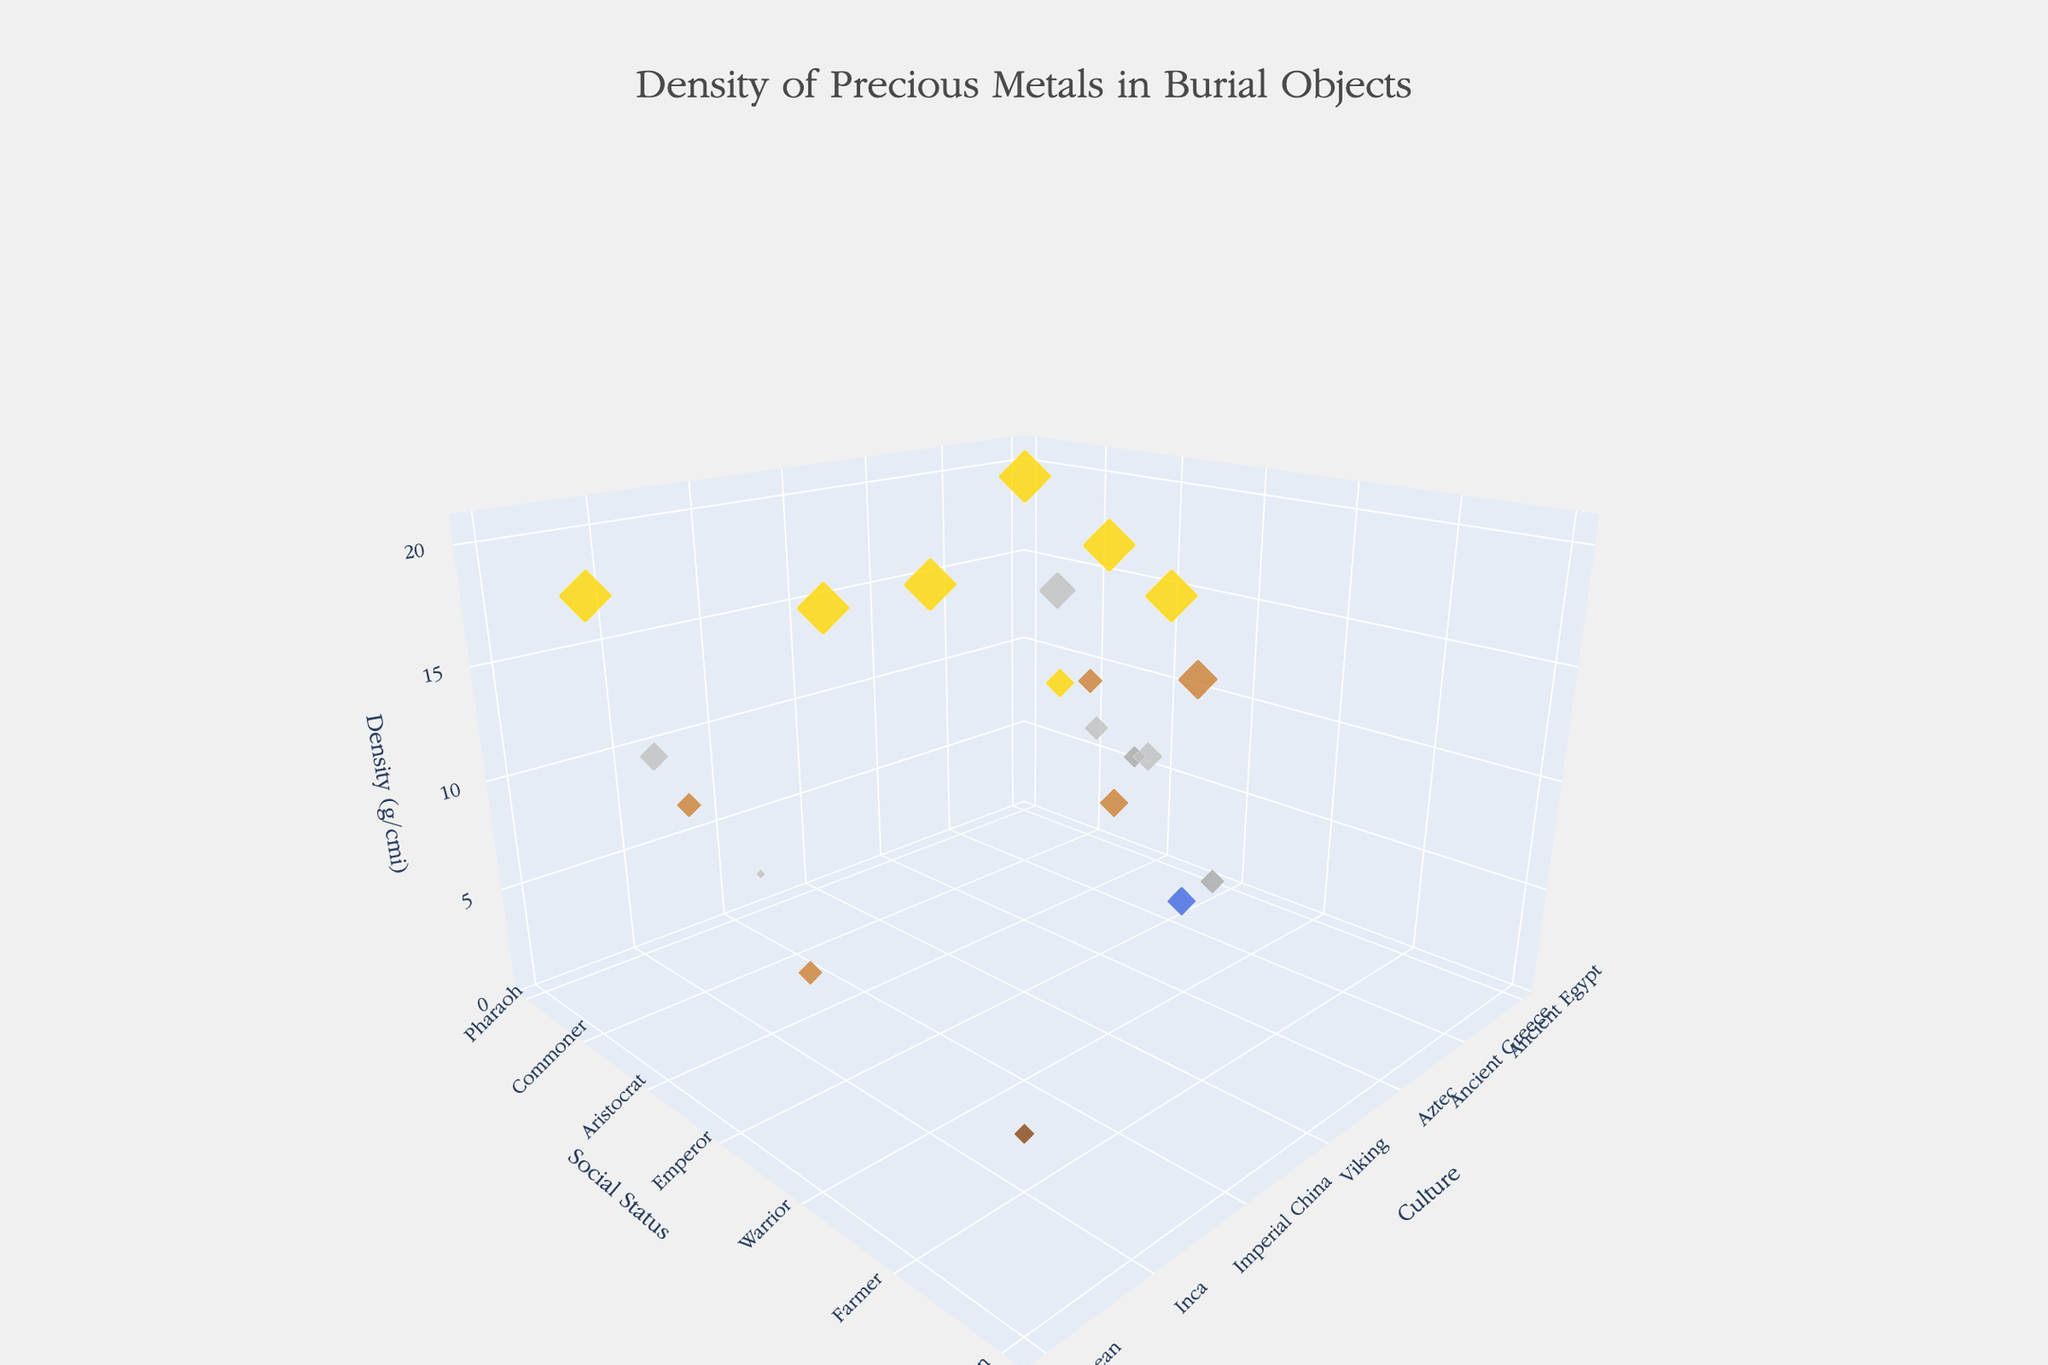what is the highest density metal used in burial artifacts? The plot shows various metals used in burial artifacts scattered across different cultures and social statuses, with density values on the z-axis. Identify the maximum z-value in the plot, which is 19.3 g/cm³, representing gold.
Answer: gold What culture used the most variety of metals in their burial artifacts? Observe the plot and count unique metal types for each culture by noting the different colors and data points within each cultural category on the x-axis. Ancient Egypt, Ancient Greece, and Imperial China each have a variety of different metals shown.
Answer: Ancient Egypt, Ancient Greece, Imperial China Which social status is associated with the densest metals across all cultures? Scan the y-axis (Social Status) for the data points with the highest z-axis values (density). The highest values correspond to ‘Emperor’, ‘Pharaoh’, and ‘King’, all associated with gold.
Answer: Emperor, Pharaoh, King How does the density of metals used by Vikings for Chieftains compare to those used for Farmers? Locate the Viking culture on the x-axis and identify the z values for 'Chieftain' and 'Farmer' on the y-axis. Chieftains have gold (19.3 g/cm³) and Farmers have bronze (8.73 g/cm³), showing that Chieftains used denser metals.
Answer: Chieftains used denser metals than Farmers Name a metal with lower density than Iron used in any culture’s burial artifacts. Locate Iron on the z-axis (7.874 g/cm³) and check for metals with a lower z value across different cultures. Jade, used in Imperial China, has a density of 3.3 g/cm³.
Answer: jade Among commoners across all cultures, which metal shows the highest density? Find the ‘Commoner’ status on the y-axis across all cultures and compare z-values. Copper, used in Ancient Egypt and the Inca culture, with a density of 8.96 g/cm³, is the highest among commoners.
Answer: copper What is the average density of metals used by Ancient Greek aristocrats and citizens? Locate ‘Aristocrat’ and ‘Citizen’ under Ancient Greece on the x and y-axis. Bronze is used by Aristocrats (8.73 g/cm³) and Iron by Citizens (7.874 g/cm³). The average is (8.73 + 7.874) / 2 = 8.302 g/cm³.
Answer: 8.302 g/cm³ Identify the heaviest and lightest metals used by the Inca culture. Check the z-values for the Inca culture. The highest density metal is Gold (19.3 g/cm³) and the lowest density metal is Copper (8.96 g/cm³).
Answer: gold, copper Which social status in Imperial China utilized multiple types of metals based on the plot? Observe the y-axis marking for Imperial China and identify data points for different metals. 'Noble' and ‘Scholar’ both have different metals - Jade and Silver.
Answer: noble, scholar 